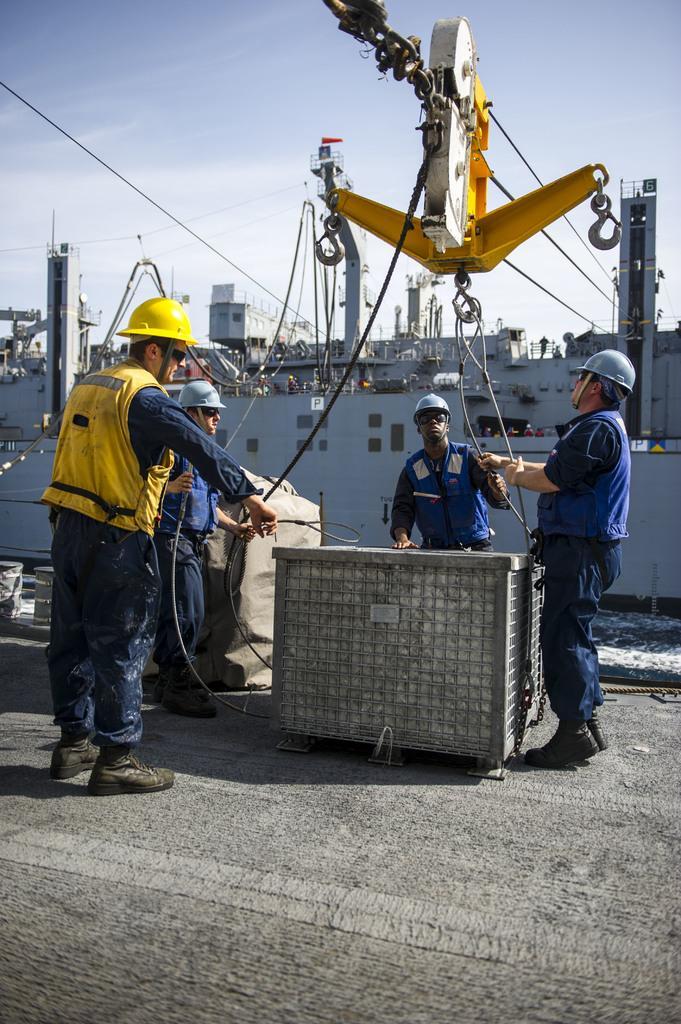How would you summarize this image in a sentence or two? This is an outside view. Here I can see four men standing on the ground. In the middle of these persons there is a box. In the background there is a ship and there are many objects on this. At the top of the image there is a crane and also I can see the ropes. At the top of the image I can see the sky. 